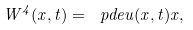Convert formula to latex. <formula><loc_0><loc_0><loc_500><loc_500>W ^ { 4 } ( x , t ) = \ p d e { u ( x , t ) } { x } ,</formula> 